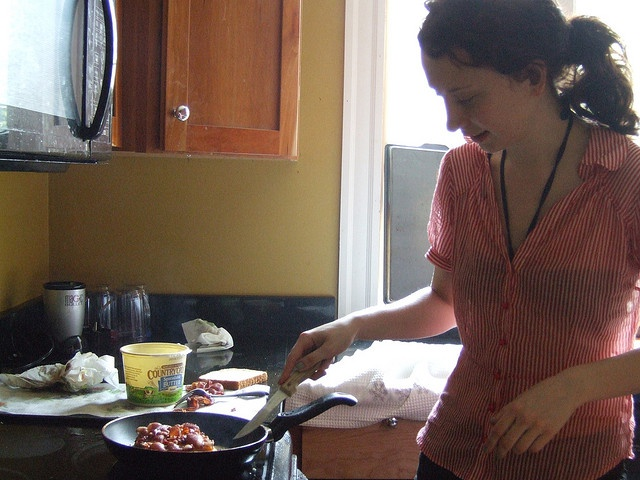Describe the objects in this image and their specific colors. I can see people in white, maroon, black, and brown tones, microwave in white, darkgray, gray, and black tones, oven in white, black, gray, and darkgray tones, cup in white, black, gray, and darkgray tones, and cup in white, black, gray, and darkblue tones in this image. 